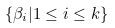Convert formula to latex. <formula><loc_0><loc_0><loc_500><loc_500>\left \{ \beta _ { i } | 1 \leq i \leq k \right \}</formula> 